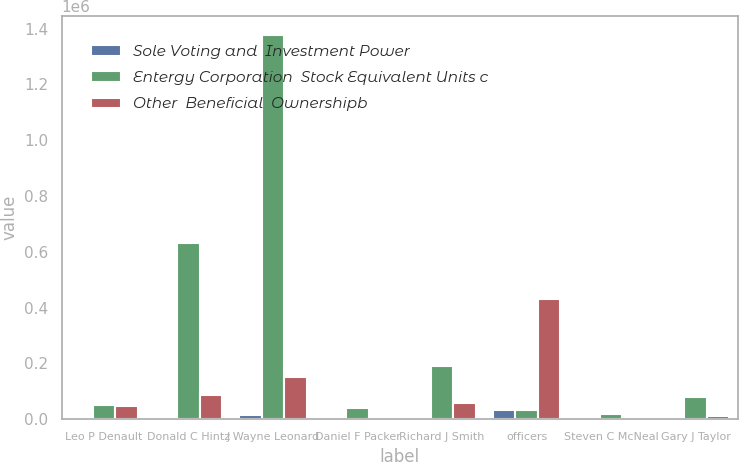Convert chart. <chart><loc_0><loc_0><loc_500><loc_500><stacked_bar_chart><ecel><fcel>Leo P Denault<fcel>Donald C Hintz<fcel>J Wayne Leonard<fcel>Daniel F Packer<fcel>Richard J Smith<fcel>officers<fcel>Steven C McNeal<fcel>Gary J Taylor<nl><fcel>Sole Voting and  Investment Power<fcel>951<fcel>4963<fcel>13433<fcel>543<fcel>1658<fcel>33293<fcel>5237<fcel>1198<nl><fcel>Entergy Corporation  Stock Equivalent Units c<fcel>52423<fcel>630000<fcel>1.3768e+06<fcel>40133<fcel>190538<fcel>33293<fcel>19000<fcel>79200<nl><fcel>Other  Beneficial  Ownershipb<fcel>48924<fcel>87605<fcel>150731<fcel>5446<fcel>56875<fcel>430897<fcel>3624<fcel>12094<nl></chart> 